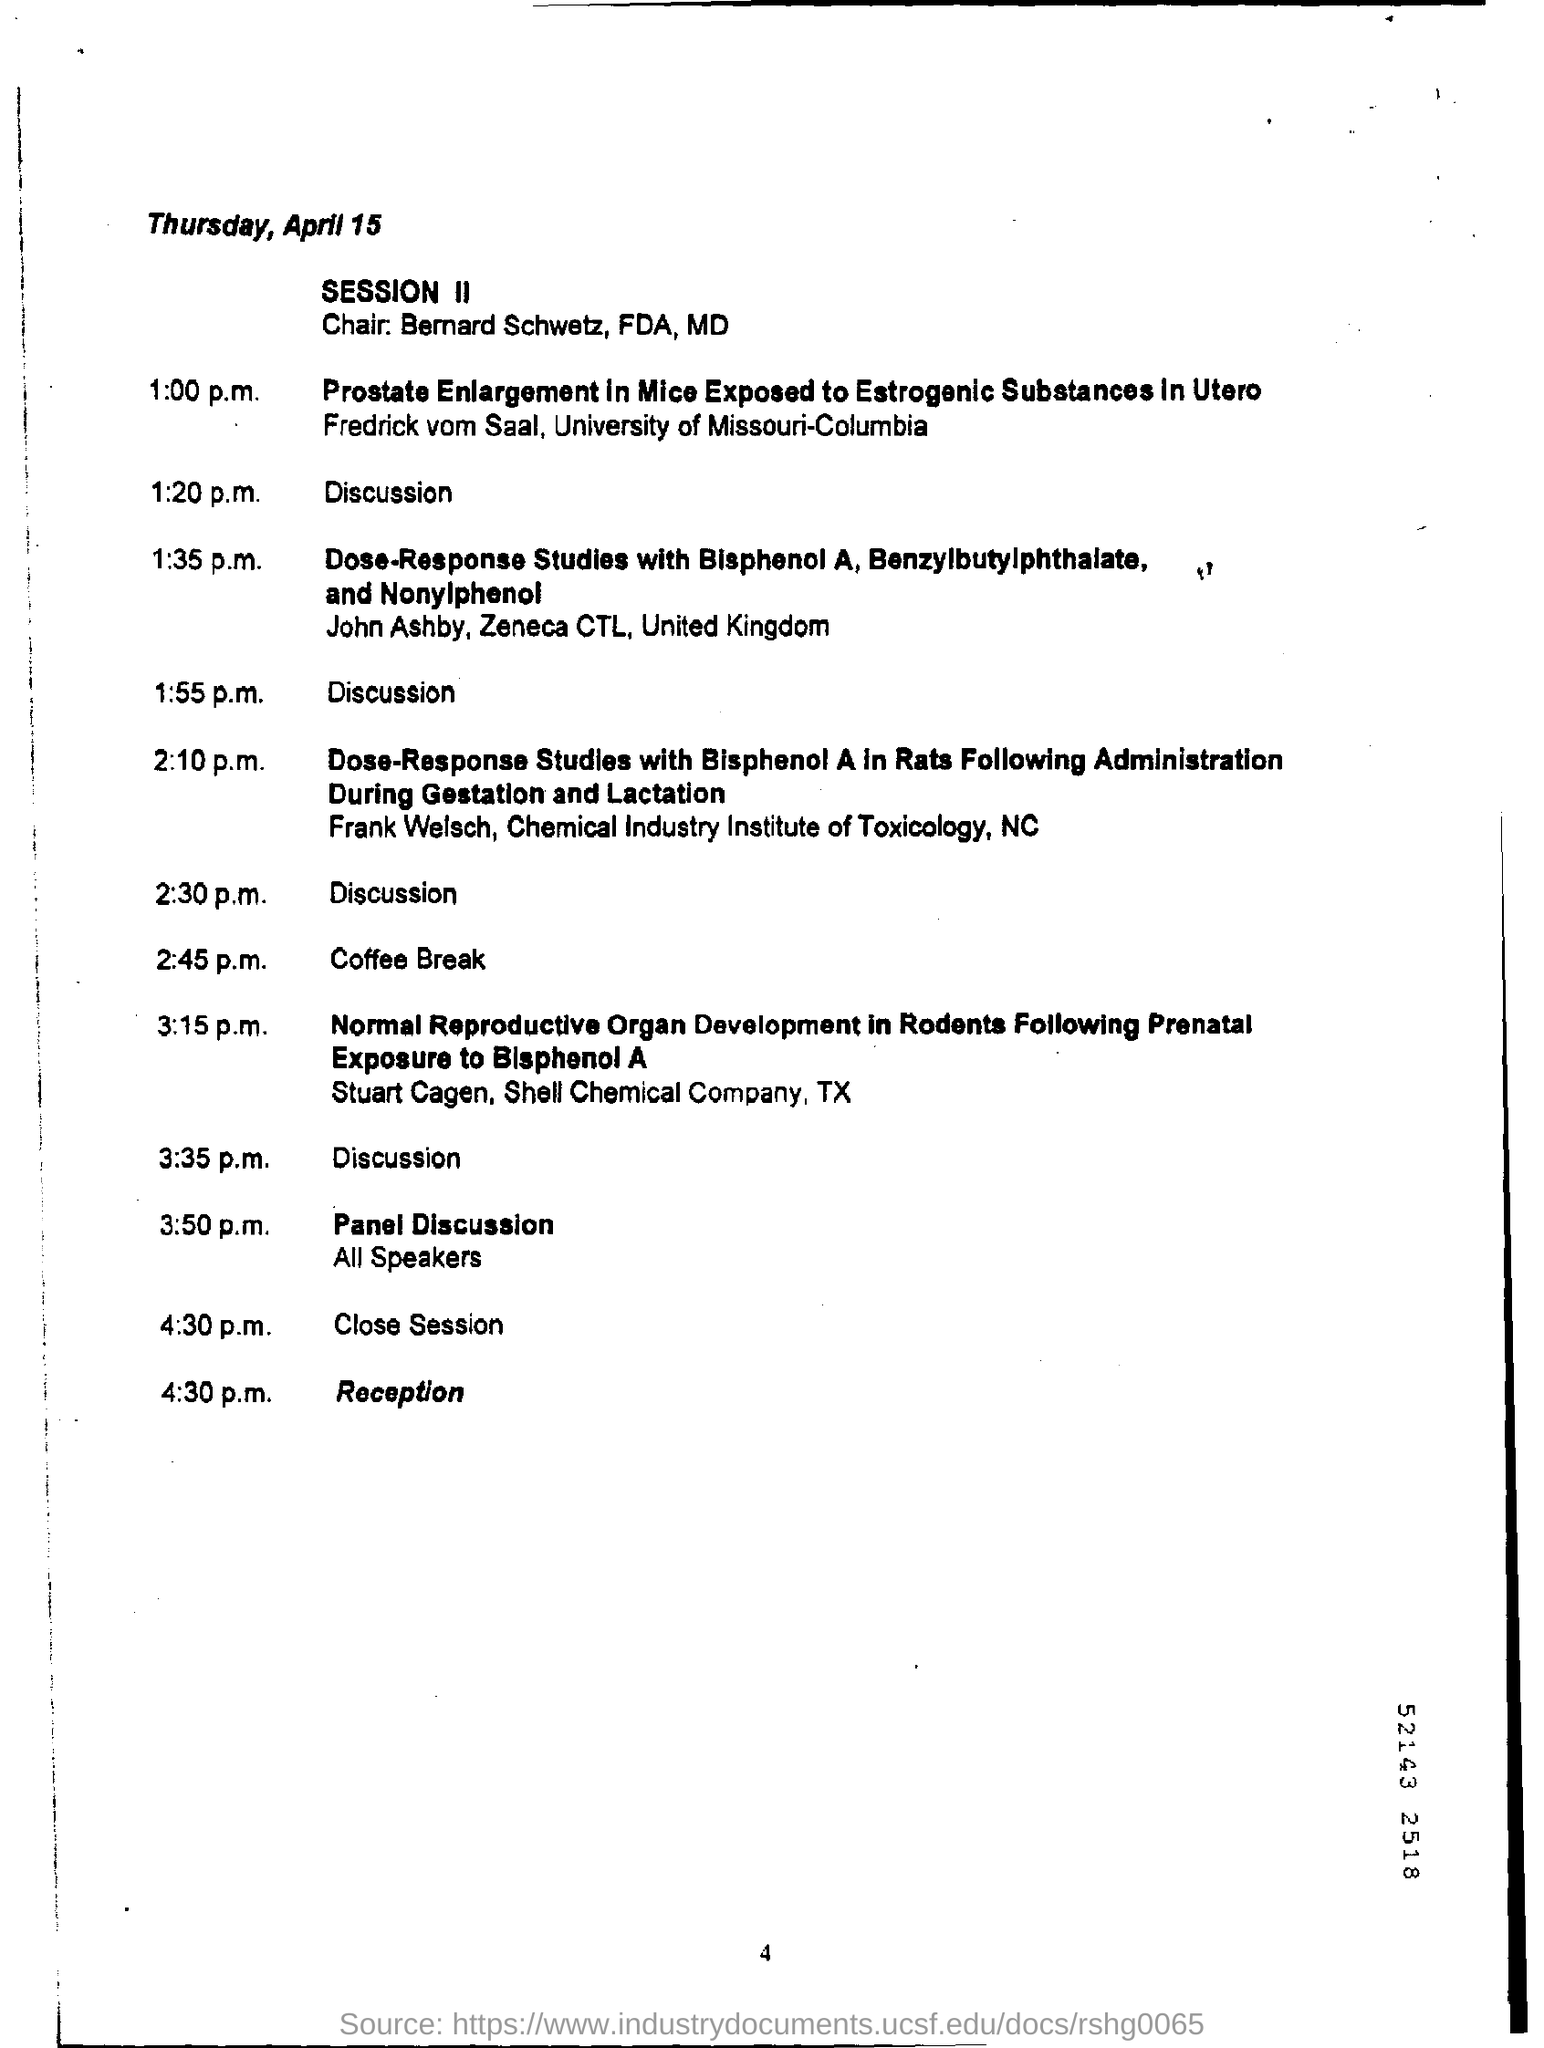Which day is April 15?
Your answer should be compact. Thursday. 